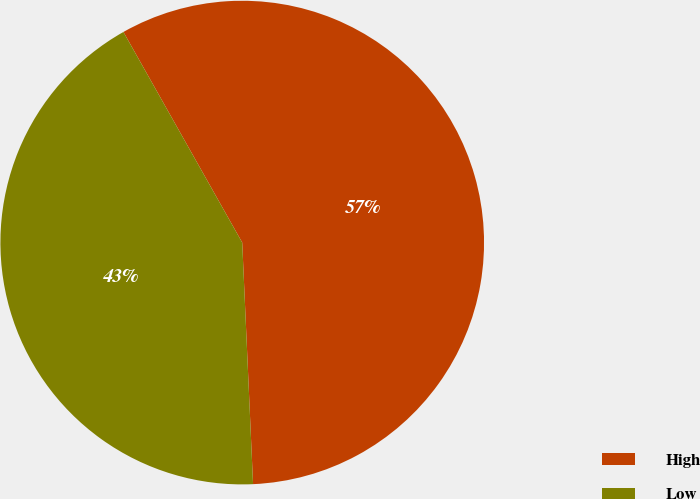Convert chart to OTSL. <chart><loc_0><loc_0><loc_500><loc_500><pie_chart><fcel>High<fcel>Low<nl><fcel>57.46%<fcel>42.54%<nl></chart> 